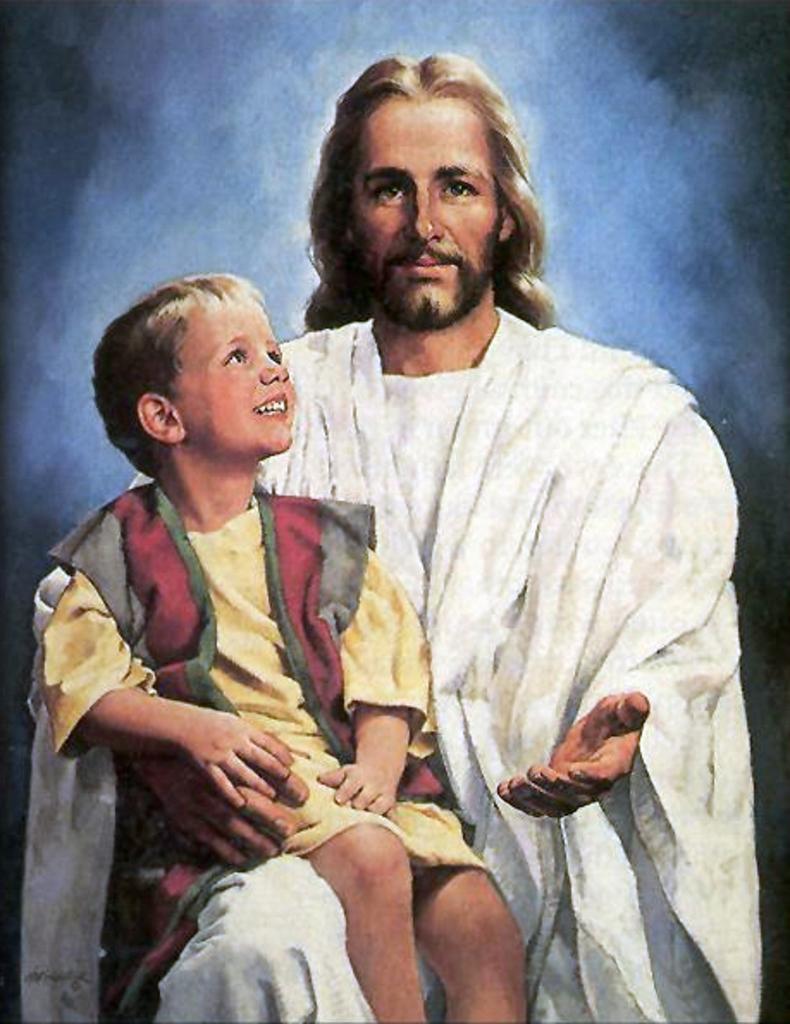Could you give a brief overview of what you see in this image? In the image in the center we can see one person sitting and holding one kid. And they were smiling,which we can see on their faces. 